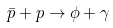<formula> <loc_0><loc_0><loc_500><loc_500>\bar { p } + p \to \phi + \gamma</formula> 